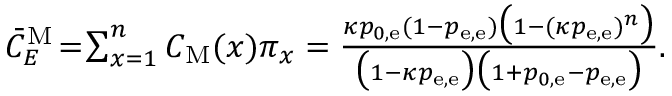Convert formula to latex. <formula><loc_0><loc_0><loc_500><loc_500>\begin{array} { r } { \bar { C } _ { E } ^ { M } \, = \, \sum _ { x = 1 } ^ { n } C _ { M } ( x ) \pi _ { x } = \frac { \kappa p _ { 0 , e } ( 1 - p _ { e , e } ) \left ( 1 - ( \kappa p _ { e , e } ) ^ { n } \right ) } { \left ( 1 - \kappa p _ { e , e } \right ) \left ( 1 + p _ { 0 , e } - p _ { e , e } \right ) } . } \end{array}</formula> 